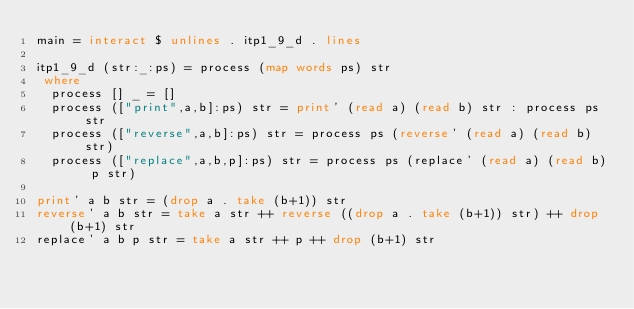Convert code to text. <code><loc_0><loc_0><loc_500><loc_500><_Haskell_>main = interact $ unlines . itp1_9_d . lines

itp1_9_d (str:_:ps) = process (map words ps) str
 where
  process [] _ = []
  process (["print",a,b]:ps) str = print' (read a) (read b) str : process ps str
  process (["reverse",a,b]:ps) str = process ps (reverse' (read a) (read b) str)
  process (["replace",a,b,p]:ps) str = process ps (replace' (read a) (read b) p str)

print' a b str = (drop a . take (b+1)) str
reverse' a b str = take a str ++ reverse ((drop a . take (b+1)) str) ++ drop (b+1) str
replace' a b p str = take a str ++ p ++ drop (b+1) str</code> 